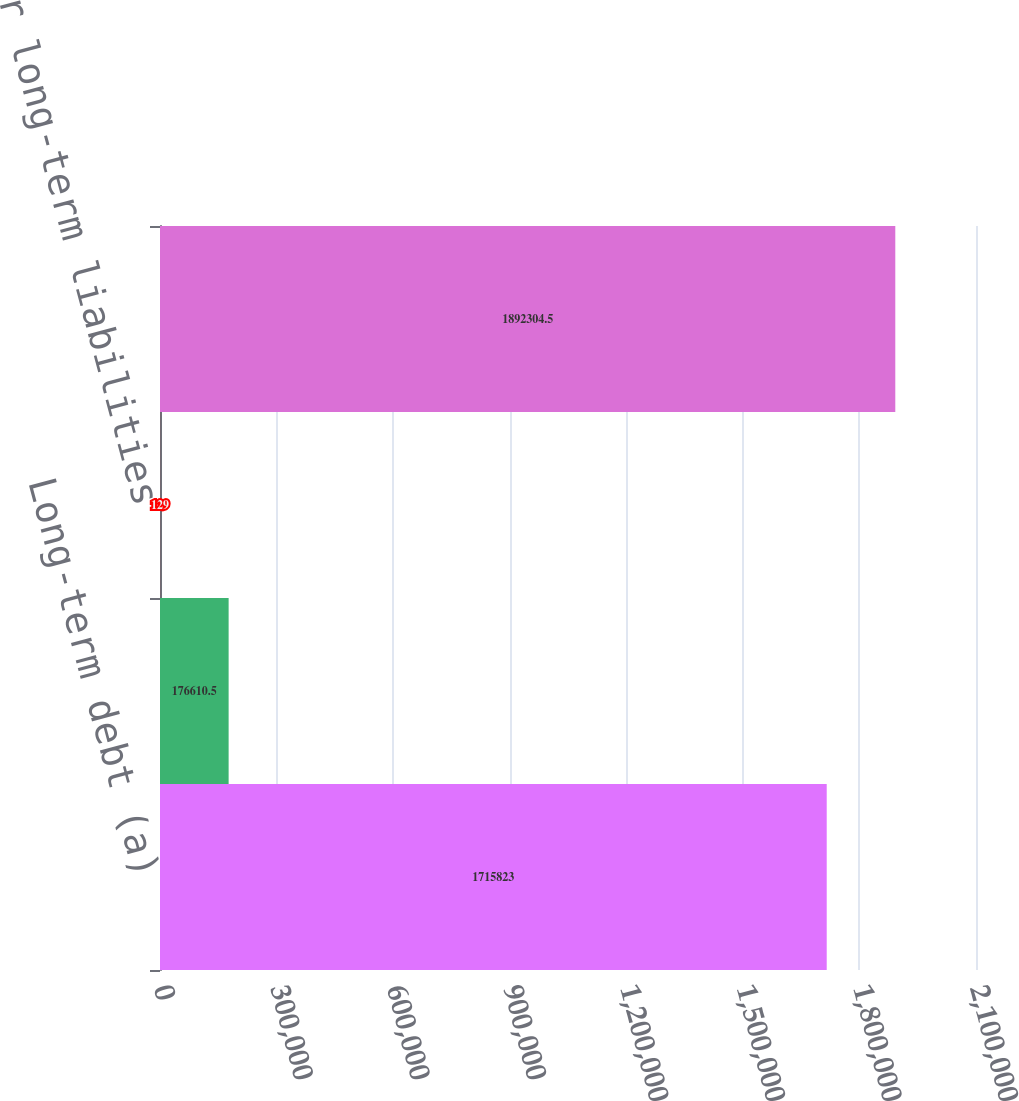Convert chart to OTSL. <chart><loc_0><loc_0><loc_500><loc_500><bar_chart><fcel>Long-term debt (a)<fcel>Operating lease obligations<fcel>Other long-term liabilities<fcel>Total contractual obligations<nl><fcel>1.71582e+06<fcel>176610<fcel>129<fcel>1.8923e+06<nl></chart> 